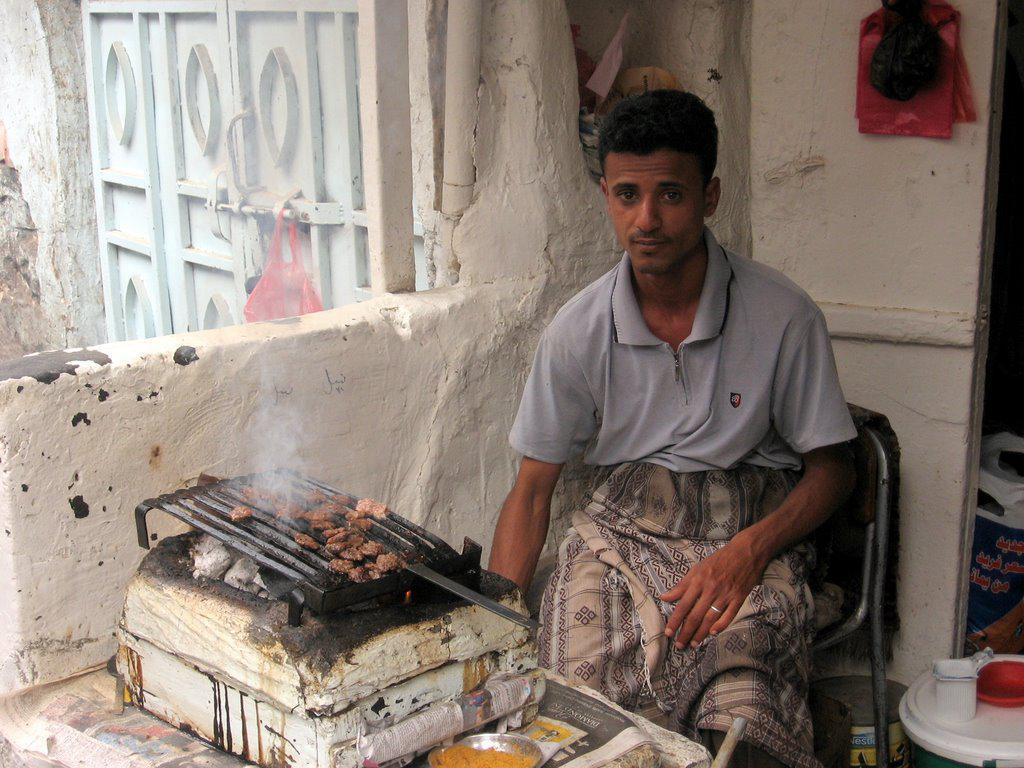What is the man in the image doing? The man is sitting on a chair in the image. What architectural feature can be seen in the image? There is a gate in the image. What other structures are present in the image? There is a wall and a door in the image. Where is the grandfather hiding the bucket in the cellar in the image? There is no mention of a grandfather, bucket, or cellar in the image. 